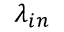<formula> <loc_0><loc_0><loc_500><loc_500>\lambda _ { i n }</formula> 